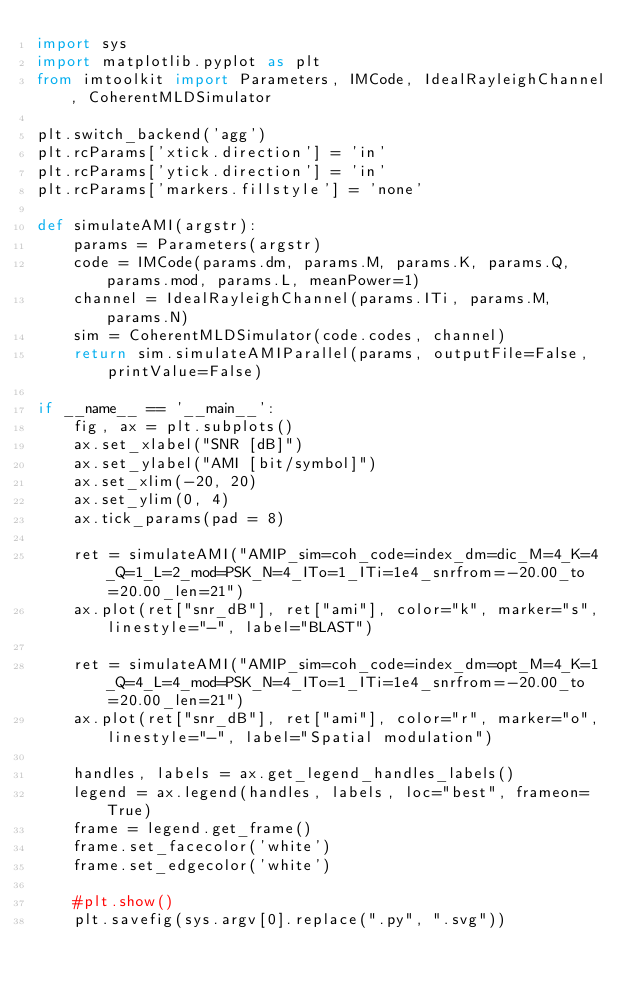Convert code to text. <code><loc_0><loc_0><loc_500><loc_500><_Python_>import sys
import matplotlib.pyplot as plt
from imtoolkit import Parameters, IMCode, IdealRayleighChannel, CoherentMLDSimulator

plt.switch_backend('agg')
plt.rcParams['xtick.direction'] = 'in'
plt.rcParams['ytick.direction'] = 'in'
plt.rcParams['markers.fillstyle'] = 'none'

def simulateAMI(argstr):
    params = Parameters(argstr)
    code = IMCode(params.dm, params.M, params.K, params.Q, params.mod, params.L, meanPower=1)
    channel = IdealRayleighChannel(params.ITi, params.M, params.N)
    sim = CoherentMLDSimulator(code.codes, channel)
    return sim.simulateAMIParallel(params, outputFile=False, printValue=False)

if __name__ == '__main__':
    fig, ax = plt.subplots()
    ax.set_xlabel("SNR [dB]")
    ax.set_ylabel("AMI [bit/symbol]")
    ax.set_xlim(-20, 20)
    ax.set_ylim(0, 4)
    ax.tick_params(pad = 8)

    ret = simulateAMI("AMIP_sim=coh_code=index_dm=dic_M=4_K=4_Q=1_L=2_mod=PSK_N=4_ITo=1_ITi=1e4_snrfrom=-20.00_to=20.00_len=21")
    ax.plot(ret["snr_dB"], ret["ami"], color="k", marker="s", linestyle="-", label="BLAST")

    ret = simulateAMI("AMIP_sim=coh_code=index_dm=opt_M=4_K=1_Q=4_L=4_mod=PSK_N=4_ITo=1_ITi=1e4_snrfrom=-20.00_to=20.00_len=21")
    ax.plot(ret["snr_dB"], ret["ami"], color="r", marker="o", linestyle="-", label="Spatial modulation")

    handles, labels = ax.get_legend_handles_labels()
    legend = ax.legend(handles, labels, loc="best", frameon=True)
    frame = legend.get_frame()
    frame.set_facecolor('white')
    frame.set_edgecolor('white')

    #plt.show()
    plt.savefig(sys.argv[0].replace(".py", ".svg"))
</code> 